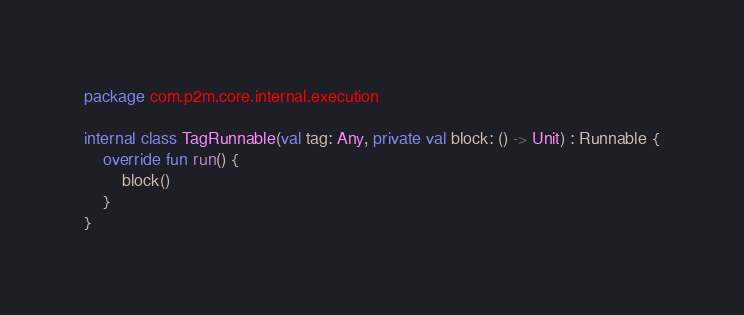<code> <loc_0><loc_0><loc_500><loc_500><_Kotlin_>package com.p2m.core.internal.execution

internal class TagRunnable(val tag: Any, private val block: () -> Unit) : Runnable {
    override fun run() {
        block()
    }
}</code> 